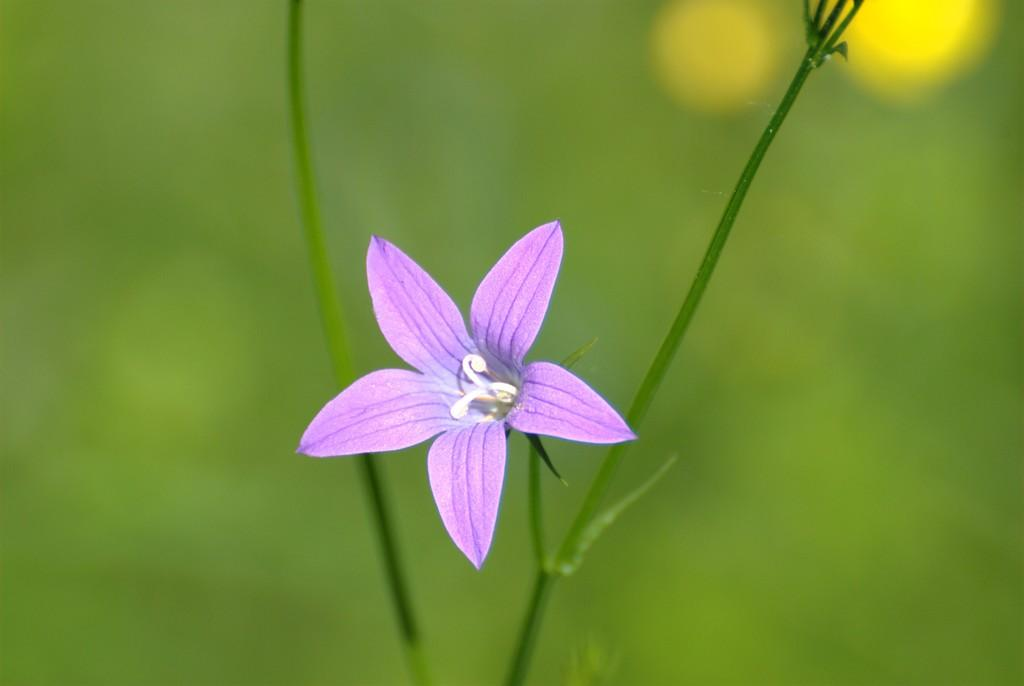What is the main subject of the image? There is a flower in the image. What colors can be seen on the flower? The flower has purple and white colors. What color is the background of the image? The background of the image is green in color. Can you see any respectful fairies in the image? There are no fairies, respectful or otherwise, present in the image. How many spiders are visible on the flower in the image? There are no spiders visible on the flower in the image. 